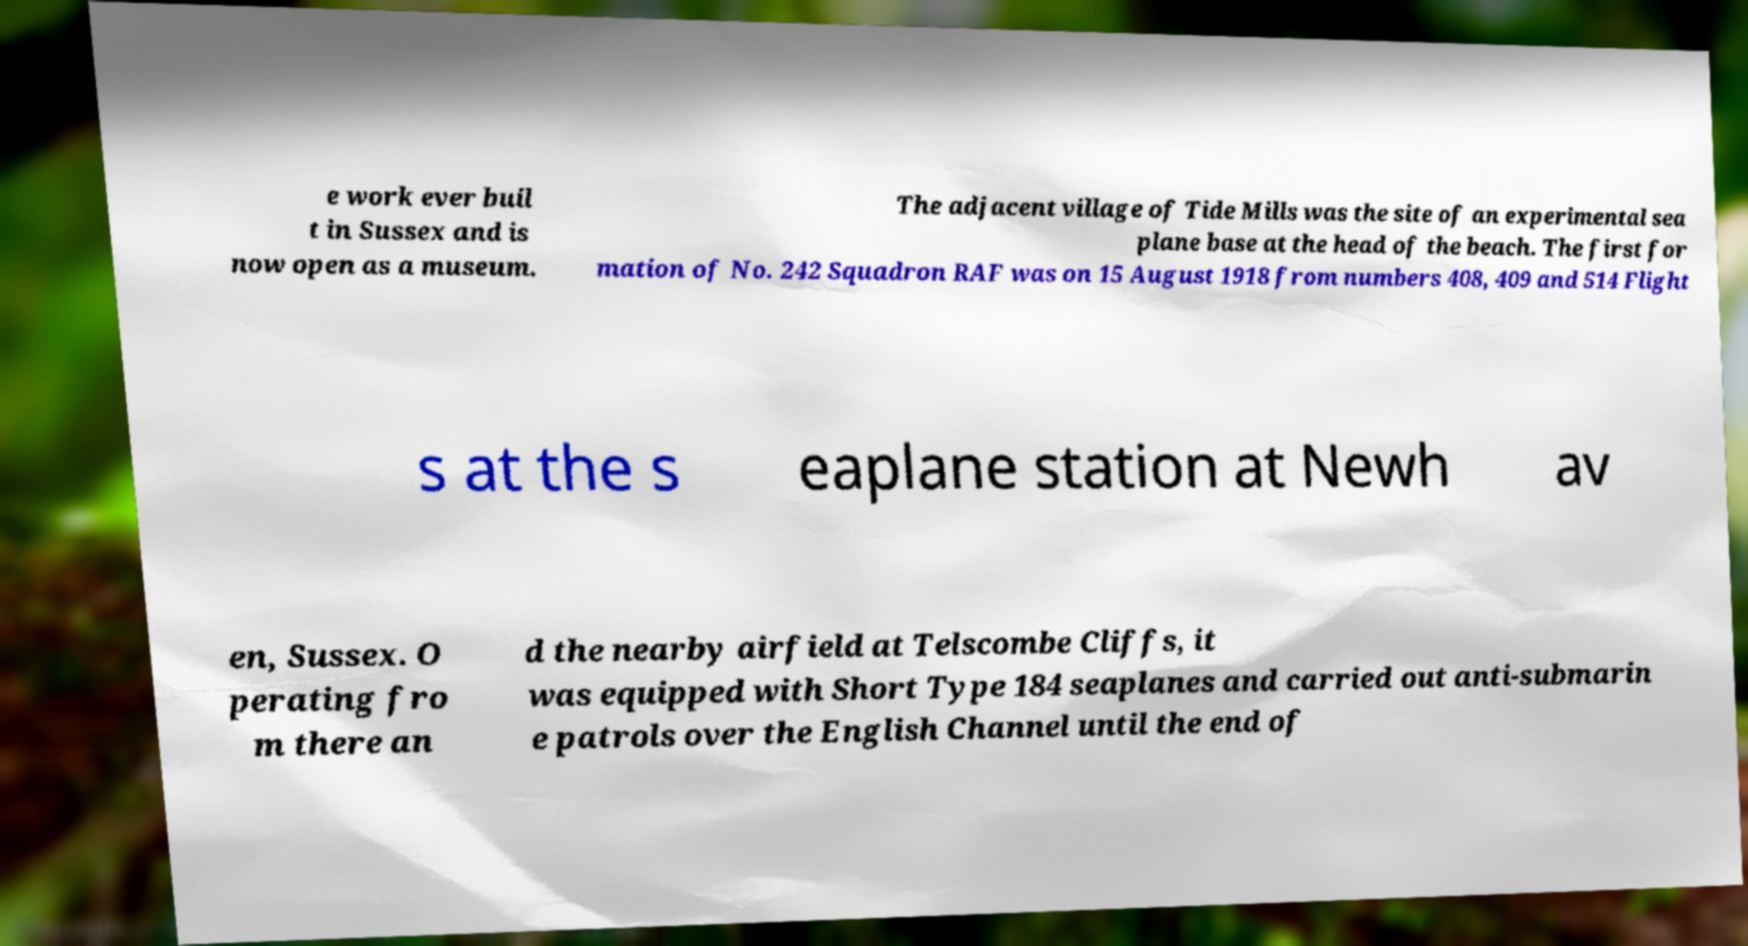I need the written content from this picture converted into text. Can you do that? e work ever buil t in Sussex and is now open as a museum. The adjacent village of Tide Mills was the site of an experimental sea plane base at the head of the beach. The first for mation of No. 242 Squadron RAF was on 15 August 1918 from numbers 408, 409 and 514 Flight s at the s eaplane station at Newh av en, Sussex. O perating fro m there an d the nearby airfield at Telscombe Cliffs, it was equipped with Short Type 184 seaplanes and carried out anti-submarin e patrols over the English Channel until the end of 